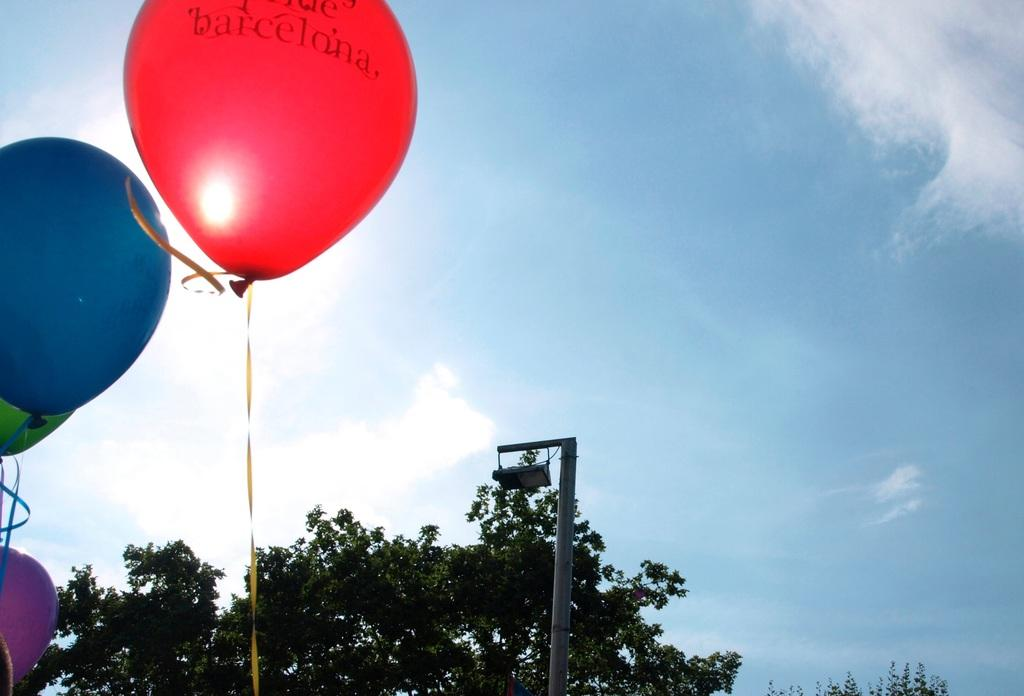What objects are present in the image that are typically associated with celebrations? There are balloons in the image, which are commonly associated with celebrations. What type of natural elements can be seen in the image? Trees and clouds are visible in the image. What is the tall, vertical object in the image? There is a pole in the image. What type of prose can be seen written on the trees in the image? There is no prose written on the trees in the image; the trees are natural elements without any text. 